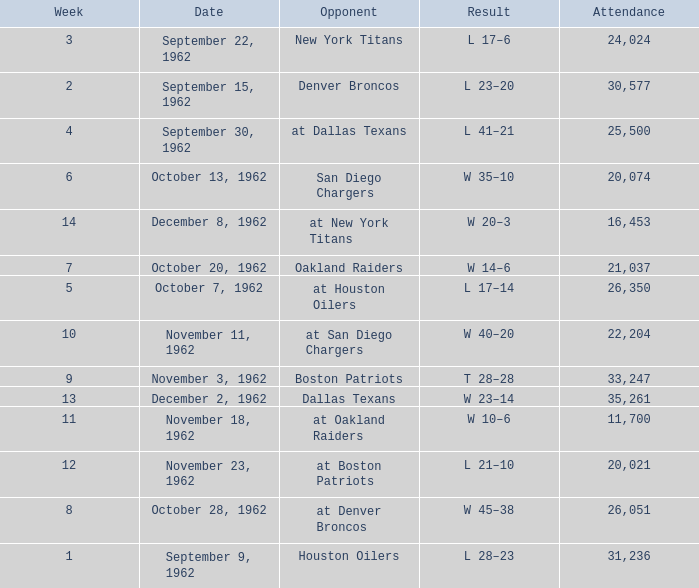What week was the attendance smaller than 22,204 on December 8, 1962? 14.0. 